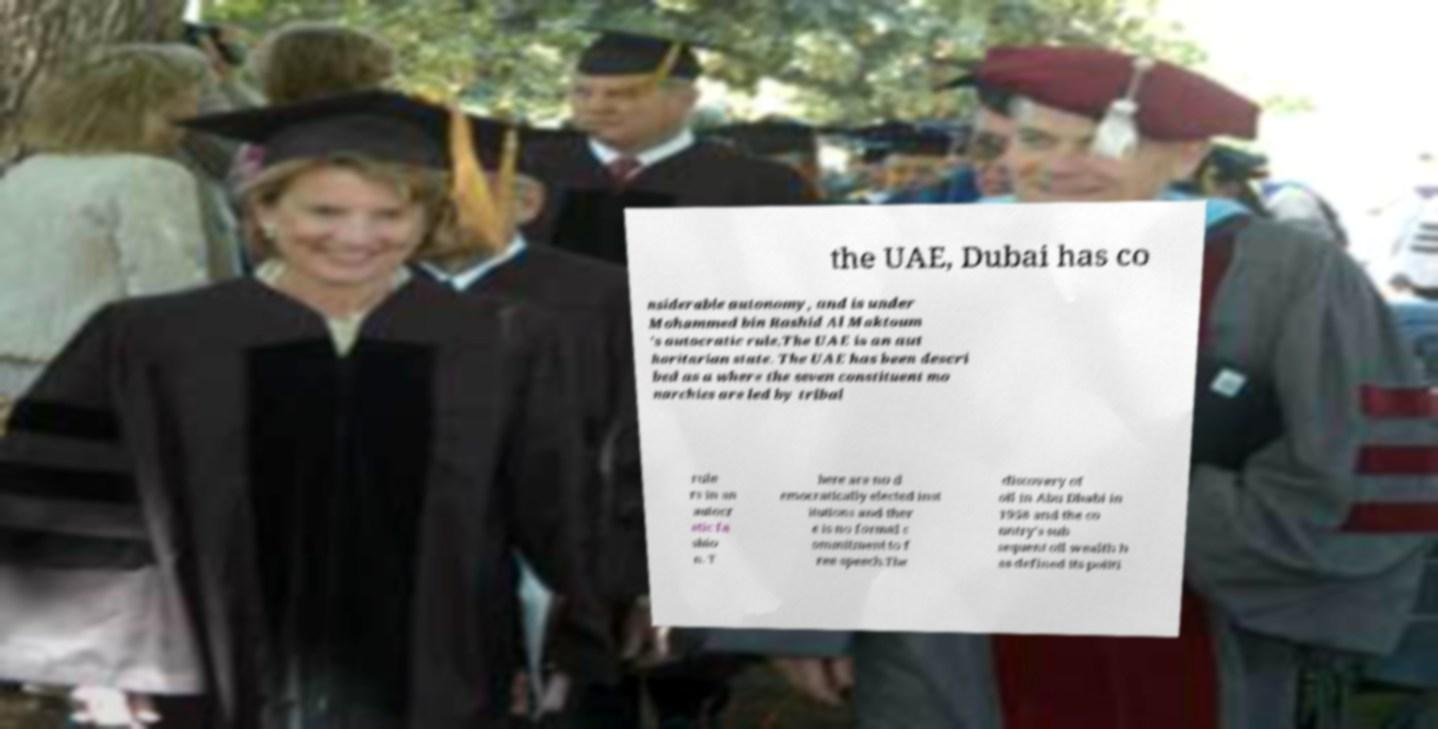Could you extract and type out the text from this image? the UAE, Dubai has co nsiderable autonomy, and is under Mohammed bin Rashid Al Maktoum 's autocratic rule.The UAE is an aut horitarian state. The UAE has been descri bed as a where the seven constituent mo narchies are led by tribal rule rs in an autocr atic fa shio n. T here are no d emocratically elected inst itutions and ther e is no formal c ommitment to f ree speech.The discovery of oil in Abu Dhabi in 1958 and the co untry's sub sequent oil wealth h as defined its politi 